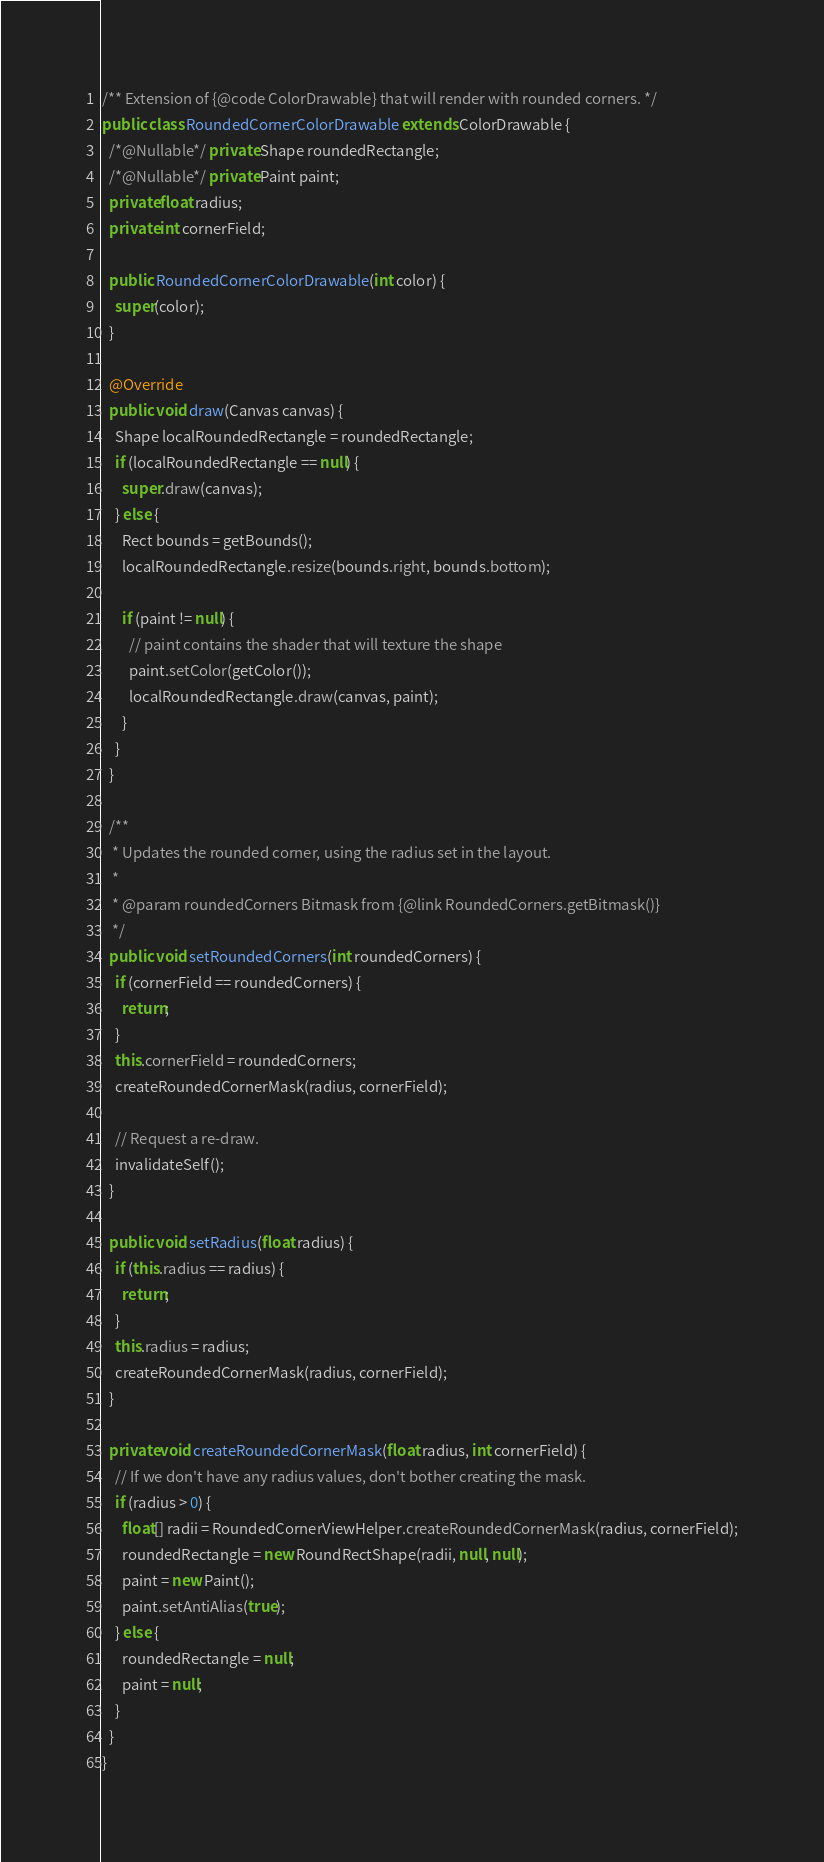<code> <loc_0><loc_0><loc_500><loc_500><_Java_>/** Extension of {@code ColorDrawable} that will render with rounded corners. */
public class RoundedCornerColorDrawable extends ColorDrawable {
  /*@Nullable*/ private Shape roundedRectangle;
  /*@Nullable*/ private Paint paint;
  private float radius;
  private int cornerField;

  public RoundedCornerColorDrawable(int color) {
    super(color);
  }

  @Override
  public void draw(Canvas canvas) {
    Shape localRoundedRectangle = roundedRectangle;
    if (localRoundedRectangle == null) {
      super.draw(canvas);
    } else {
      Rect bounds = getBounds();
      localRoundedRectangle.resize(bounds.right, bounds.bottom);

      if (paint != null) {
        // paint contains the shader that will texture the shape
        paint.setColor(getColor());
        localRoundedRectangle.draw(canvas, paint);
      }
    }
  }

  /**
   * Updates the rounded corner, using the radius set in the layout.
   *
   * @param roundedCorners Bitmask from {@link RoundedCorners.getBitmask()}
   */
  public void setRoundedCorners(int roundedCorners) {
    if (cornerField == roundedCorners) {
      return;
    }
    this.cornerField = roundedCorners;
    createRoundedCornerMask(radius, cornerField);

    // Request a re-draw.
    invalidateSelf();
  }

  public void setRadius(float radius) {
    if (this.radius == radius) {
      return;
    }
    this.radius = radius;
    createRoundedCornerMask(radius, cornerField);
  }

  private void createRoundedCornerMask(float radius, int cornerField) {
    // If we don't have any radius values, don't bother creating the mask.
    if (radius > 0) {
      float[] radii = RoundedCornerViewHelper.createRoundedCornerMask(radius, cornerField);
      roundedRectangle = new RoundRectShape(radii, null, null);
      paint = new Paint();
      paint.setAntiAlias(true);
    } else {
      roundedRectangle = null;
      paint = null;
    }
  }
}
</code> 